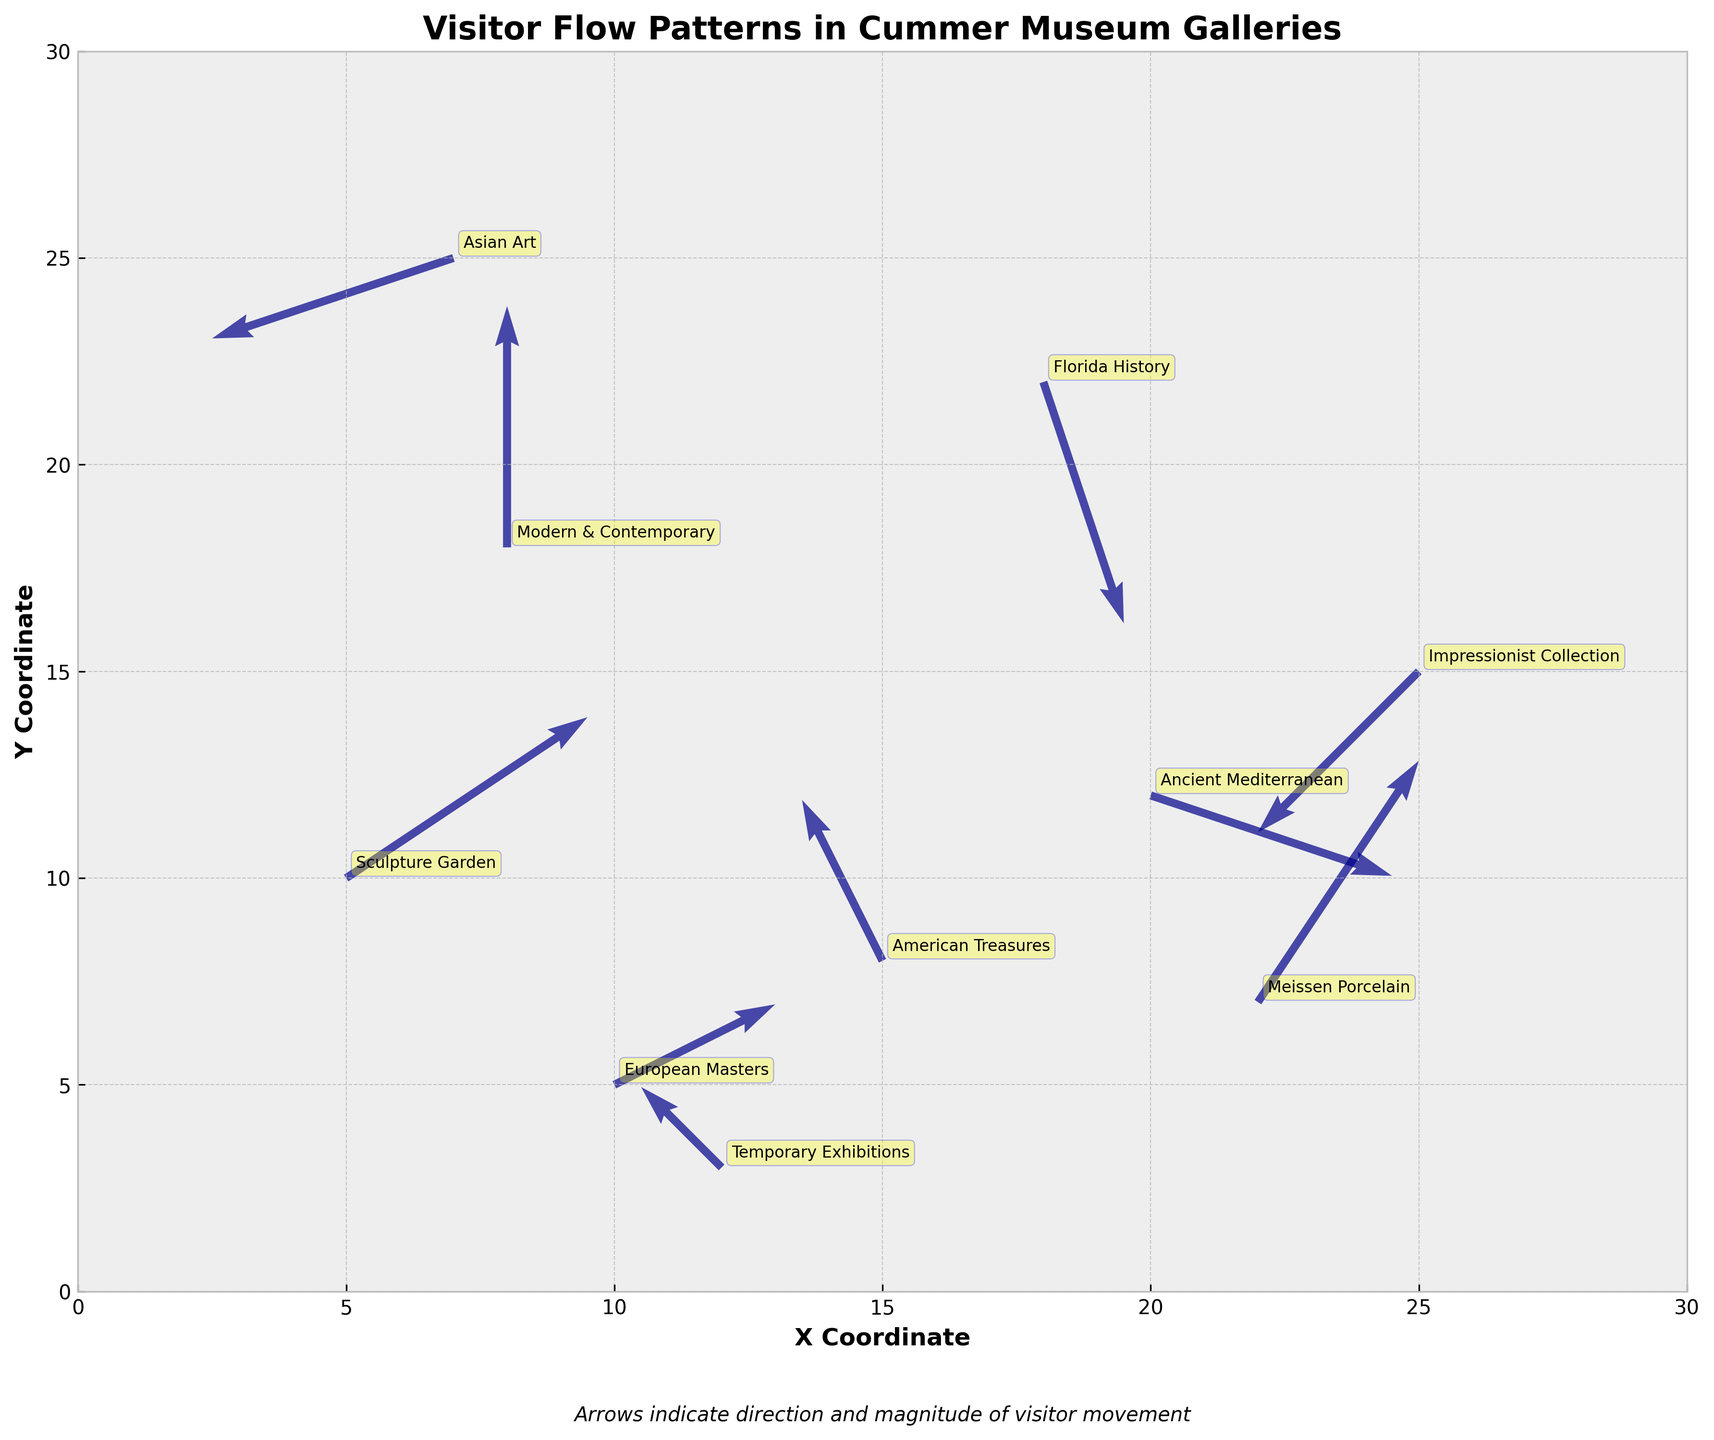What is the title of the plot? The title of the plot is usually found at the top of the figure. The rendered figure's top clearly states "Visitor Flow Patterns in Cummer Museum Galleries".
Answer: Visitor Flow Patterns in Cummer Museum Galleries What do the arrows in the plot represent? The arrows indicate the direction and magnitude of visitor movement within the different galleries of the museum. This is noted by the explanatory text below the graph: "Arrows indicate direction and magnitude of visitor movement".
Answer: Direction and magnitude of visitor movement Which gallery has the most visitors moving upward (positive y-direction)? To find the gallery with the most visitors moving upward, look for the arrow with the greatest positive value in the y-direction (v component). The "Modern & Contemporary" gallery has an arrow with a v value of 3.
Answer: Modern & Contemporary How many galleries are presented in the plot? By counting the number of distinct data points (arrows or annotations) with different gallery names, we can determine the number of galleries plotted. There are 10 distinct galleries represented in the plot.
Answer: 10 Which gallery shows the least movement (smallest combined magnitude of x and y components)? To find the gallery with the least movement, calculate the magnitude of movement (sqrt(u^2 + v^2)) for each arrow. The movement is smallest in the "Temporary Exhibitions" gallery with values (-1,1) that result in a magnitude calculation of sqrt((-1)^2 + (1)^2) = sqrt(2).
Answer: Temporary Exhibitions Between "Impressionist Collection" and "Sculpture Garden," which gallery shows more visitor movement magnitude? Calculate the magnitude of movement for both galleries using sqrt(u^2 + v^2). For "Impressionist Collection" (-2,-2): sqrt((-2)^2 + (-2)^2) = sqrt(8). For "Sculpture Garden" (3,2): sqrt((3)^2 + (2)^2) = sqrt(13). The "Sculpture Garden" has greater magnitude.
Answer: Sculpture Garden Which gallery has the largest negative x-direction movement? To find the gallery with the largest negative x-direction movement, look for the arrow with the most negative value in the u component. The "Asian Art" gallery has an x-direction (u component) value of -3.
Answer: Asian Art Are there any galleries where visitors primarily move horizontally (x-direction only)? Look for galleries with a v value of zero in their vector description. The data for "Modern & Contemporary" shows (0,3), indicating movement primarily in the y-direction, but none show exclusive horizontal movement.
Answer: No What is the range of x-coordinates in the plot? The x-coordinates range is determined from the axis limits shown, which are set at 0 to 30. This is confirmed by viewing the x-axis range on the plot.
Answer: 0 to 30 Which gallery is located at the highest y-coordinate? By identifying the highest position on the y-axis with a gallery annotation, the "Asian Art" gallery is located at the highest y-coordinate of 25.
Answer: Asian Art 